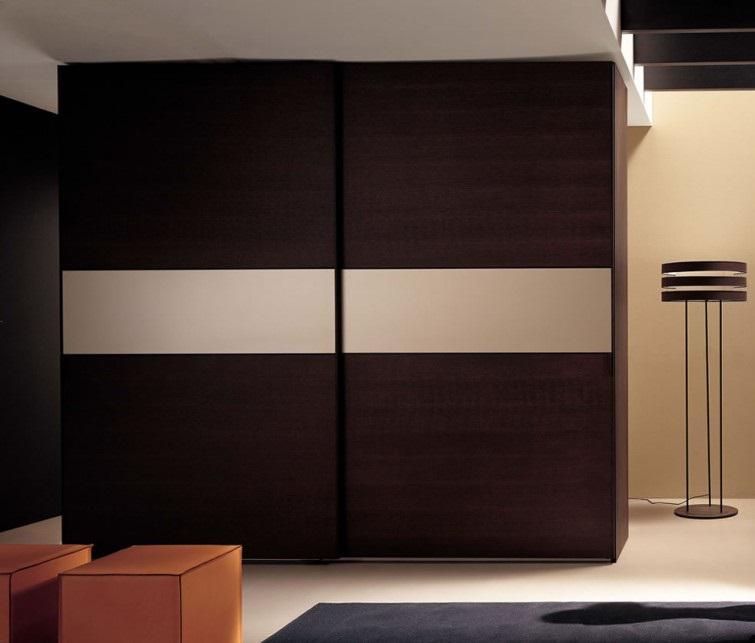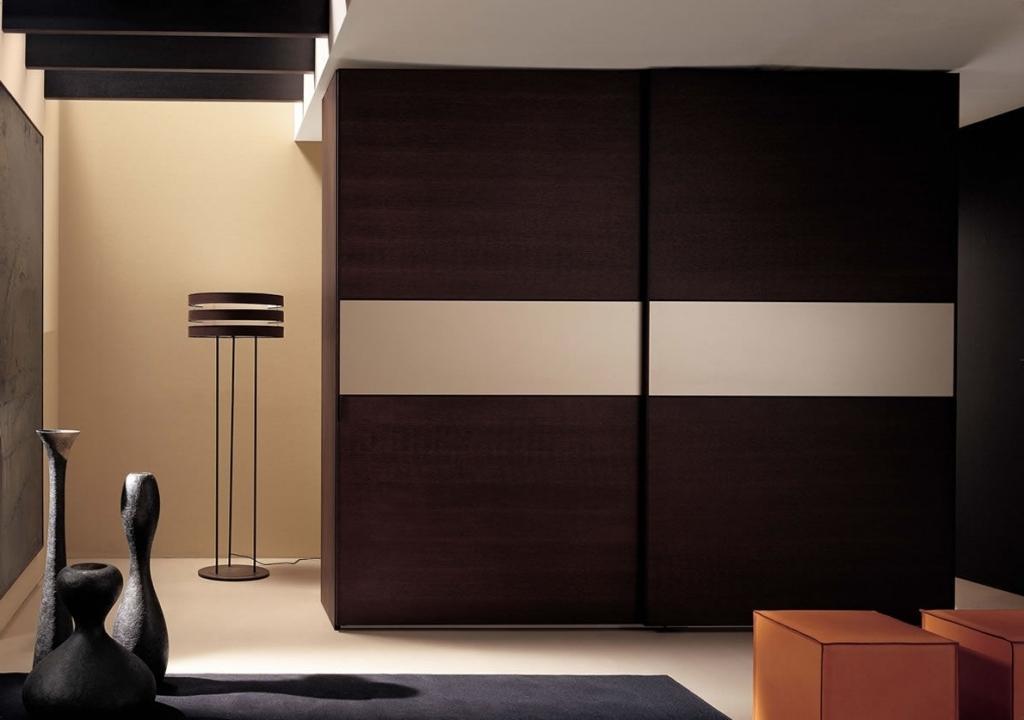The first image is the image on the left, the second image is the image on the right. Examine the images to the left and right. Is the description "There are clothes visible in one of the closets." accurate? Answer yes or no. No. The first image is the image on the left, the second image is the image on the right. Given the left and right images, does the statement "An image shows a wardrobe with pale beige panels and the sliding door partly open." hold true? Answer yes or no. No. 